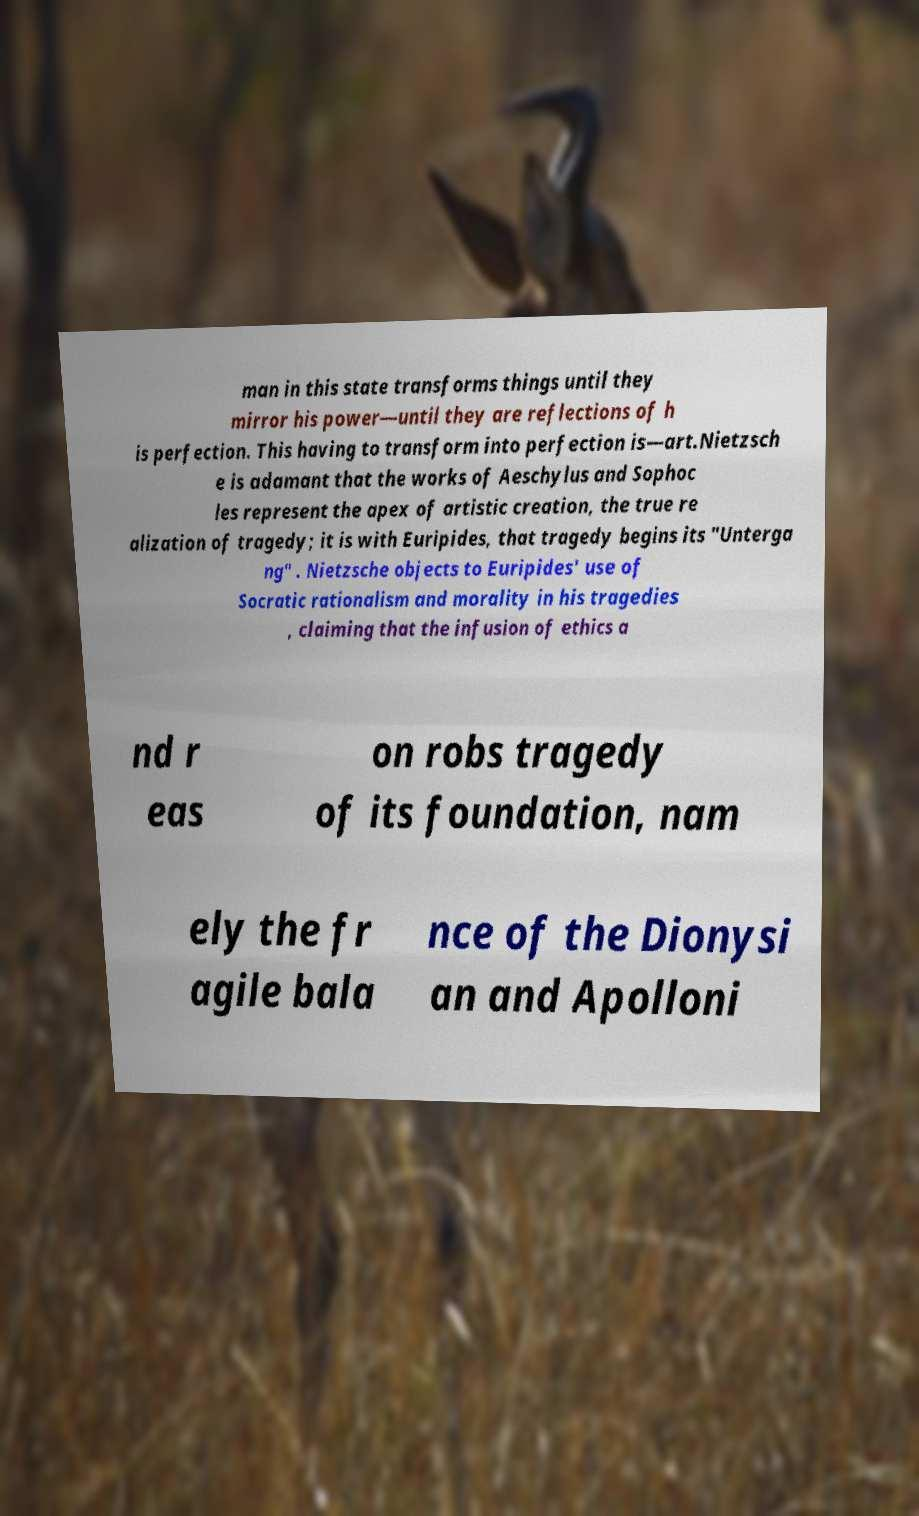What messages or text are displayed in this image? I need them in a readable, typed format. man in this state transforms things until they mirror his power—until they are reflections of h is perfection. This having to transform into perfection is—art.Nietzsch e is adamant that the works of Aeschylus and Sophoc les represent the apex of artistic creation, the true re alization of tragedy; it is with Euripides, that tragedy begins its "Unterga ng" . Nietzsche objects to Euripides' use of Socratic rationalism and morality in his tragedies , claiming that the infusion of ethics a nd r eas on robs tragedy of its foundation, nam ely the fr agile bala nce of the Dionysi an and Apolloni 